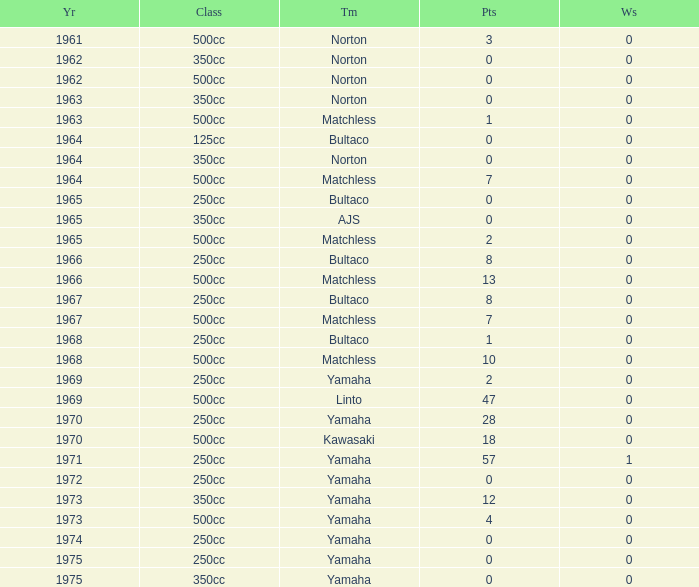Which class corresponds to more than 2 points, wins greater than 0, and a year earlier than 1973? 250cc. 